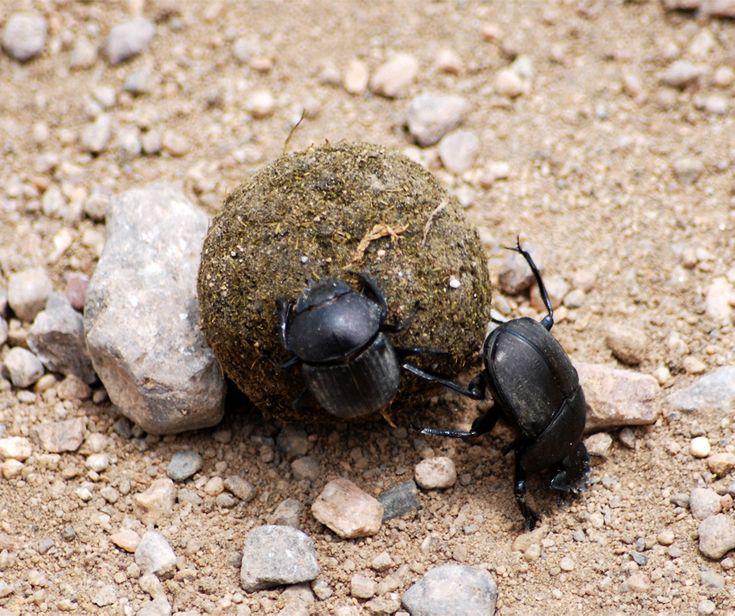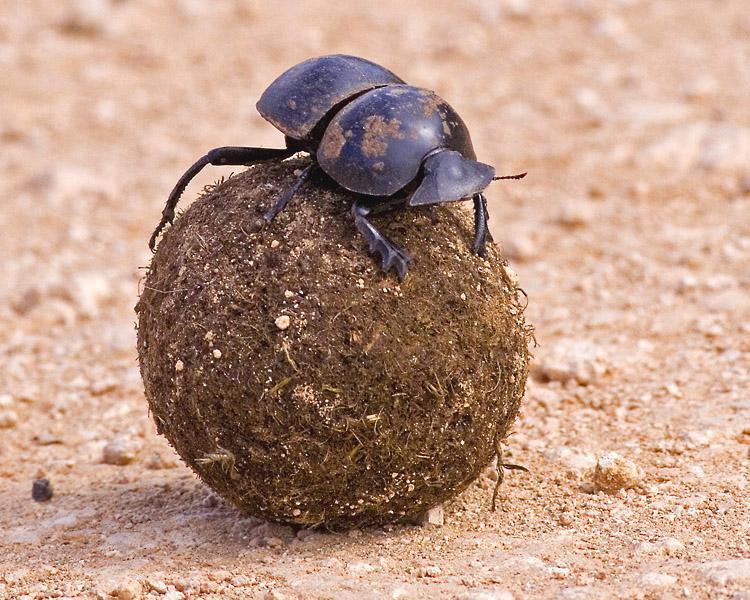The first image is the image on the left, the second image is the image on the right. For the images shown, is this caption "At least one of the beetles does not have any of its feet touching the ground." true? Answer yes or no. Yes. The first image is the image on the left, the second image is the image on the right. Given the left and right images, does the statement "Each image contains exactly one brown ball and one beetle, and the beetle in the righthand image has its front legs on the ground." hold true? Answer yes or no. No. 